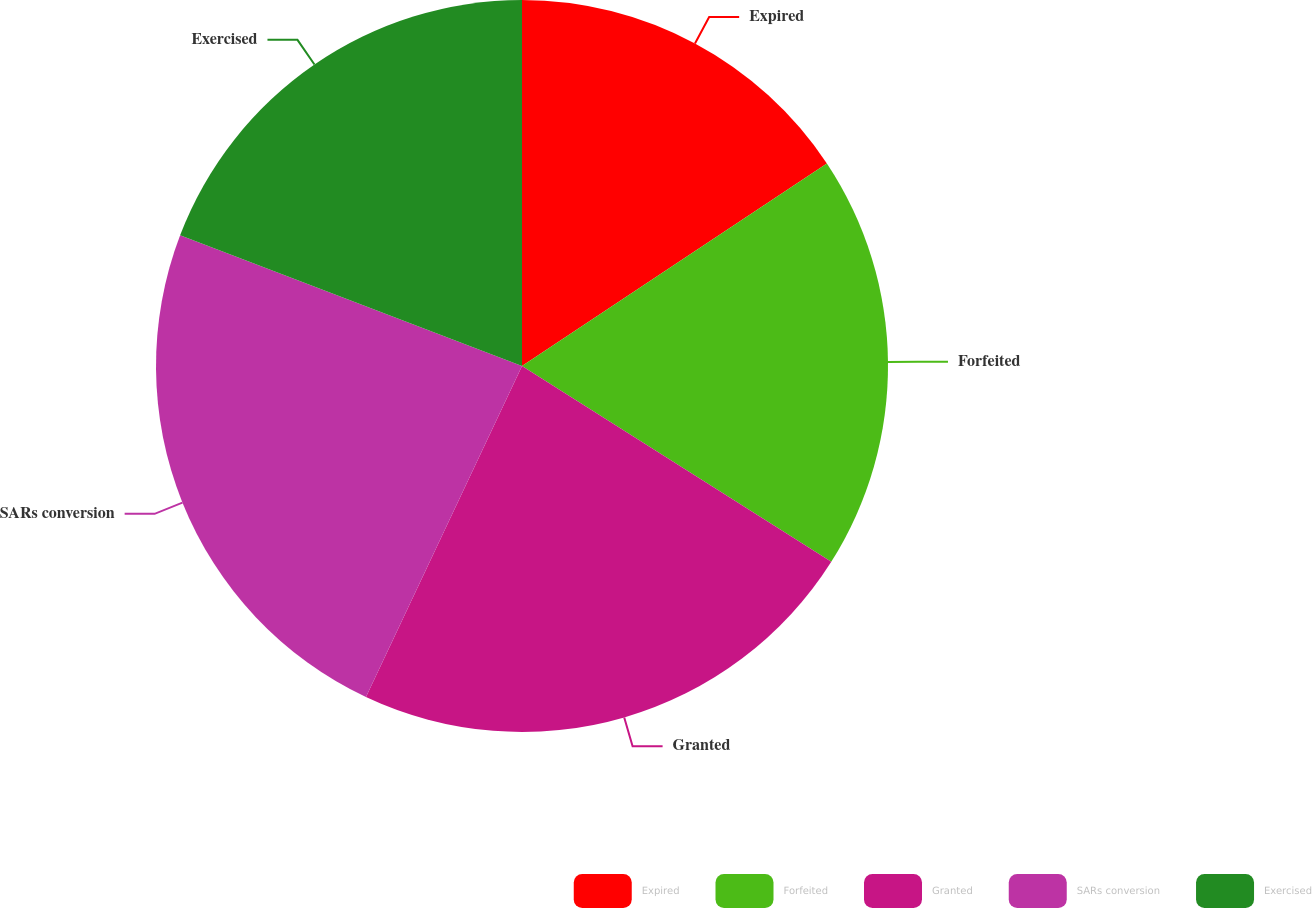Convert chart. <chart><loc_0><loc_0><loc_500><loc_500><pie_chart><fcel>Expired<fcel>Forfeited<fcel>Granted<fcel>SARs conversion<fcel>Exercised<nl><fcel>15.67%<fcel>18.31%<fcel>23.03%<fcel>23.8%<fcel>19.19%<nl></chart> 